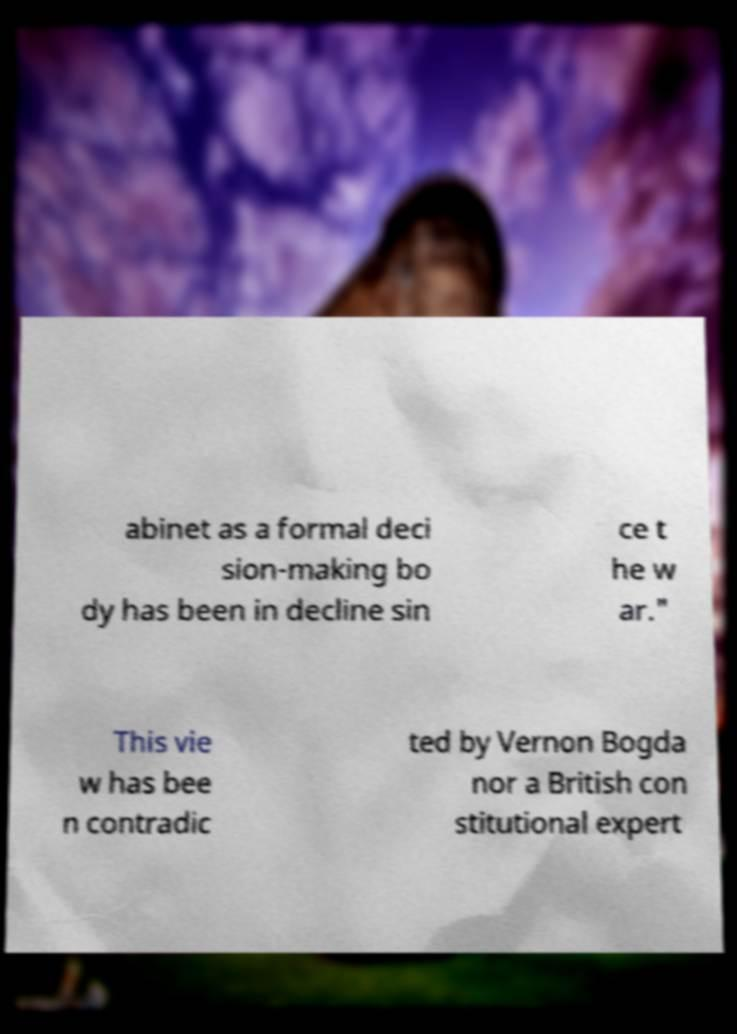Could you assist in decoding the text presented in this image and type it out clearly? abinet as a formal deci sion-making bo dy has been in decline sin ce t he w ar." This vie w has bee n contradic ted by Vernon Bogda nor a British con stitutional expert 